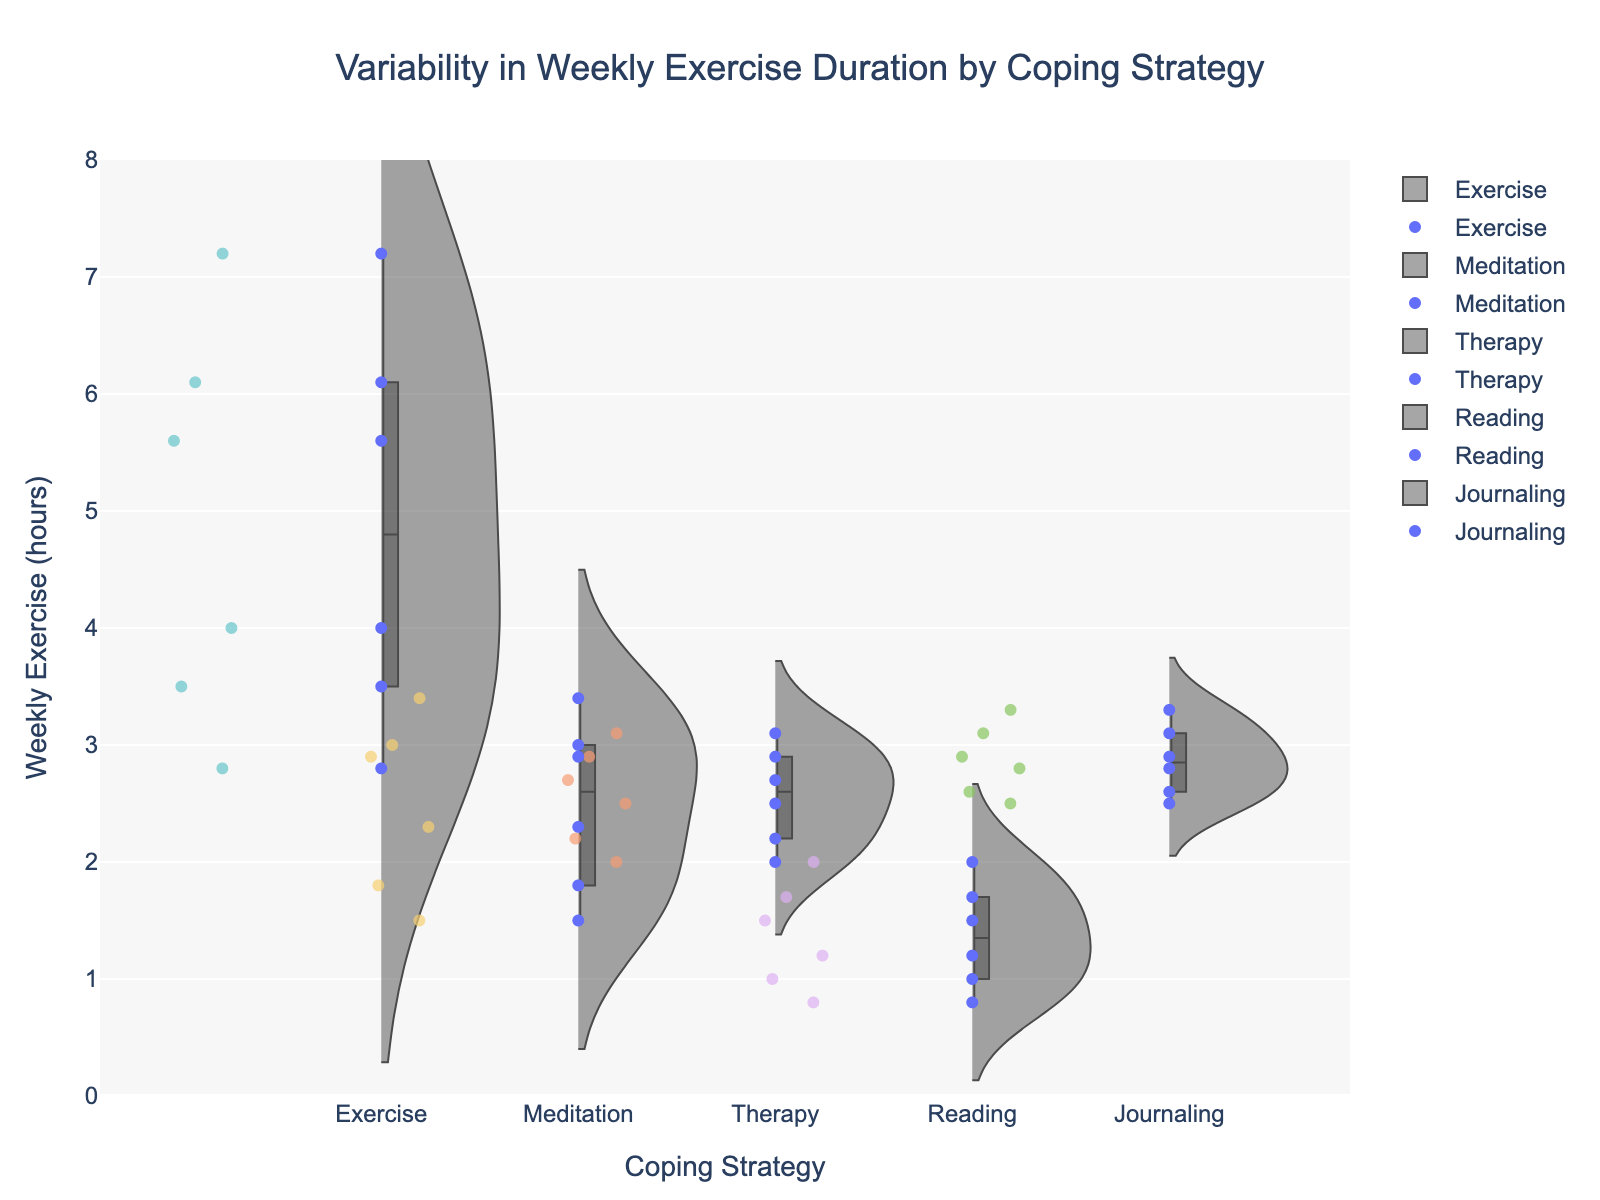What is the title of the figure? The title of the figure is located at the top and usually provides an overview of what the chart represents. In this case, the title states the purpose or subject of the data visualized.
Answer: Variability in Weekly Exercise Duration by Coping Strategy Which coping strategy has the highest median weekly exercise duration? In a violin plot, the box inside each 'violin' shows the interquartile range with the line indicating the median. By comparing these medians for each coping strategy, we can identify the highest one.
Answer: Exercise Which coping strategy shows the widest range of weekly exercise durations? The range of weekly exercise duration can be estimated by the spread of the data points and the width of the violin plot. The wider the spread, the wider the range.
Answer: Exercise How many data points are there for each coping strategy? By counting the individual data points (shown as jittered points) for each coping strategy, we can determine the number of data points. Exercise, Meditation, Therapy, Reading, and Journaling can be counted separately.
Answer: Exercise: 6, Meditation: 6, Therapy: 6, Reading: 6, Journaling: 6 Which coping strategy has the lowest maximum weekly exercise duration? The maximum weekly exercise duration for each coping strategy is indicated by the highest point within the violin plot. Comparing these points across the strategies will show the lowest maximum duration.
Answer: Reading What is the approximate interquartile range (IQR) for Meditation? The IQR is the range between the first quartile (25th percentile) and the third quartile (75th percentile) shown by the box. By estimating the values of these two quartiles from the violin plot, the IQR can be calculated.
Answer: 1.6 hours What is the difference in median weekly exercise duration between the Exercise and Therapy coping strategies? Finding the medians for both Exercise and Therapy from the box plots within the violins, we can then subtract the median of Therapy from the median of Exercise.
Answer: Approx. 2.6 hours Which coping strategy appears to have the most consistent weekly exercise duration? Consistency in weekly exercise duration can be identified by the narrowness of the violin plot and the clustering of data points around the median.
Answer: Therapy What is the approximate median weekly exercise duration for Reading? The median weekly exercise duration is indicated by the line inside the box plot within the violin for Reading. Estimating its value provides the median duration.
Answer: 1.2 hours Compare the spread of weekly exercise durations for Journaling and Meditation. Which has a greater spread? The spread of durations can be determined by the width and extent of the violin plots for Journaling and Meditation. The one with a more extensive and wider plot indicates a greater spread.
Answer: Journaling 